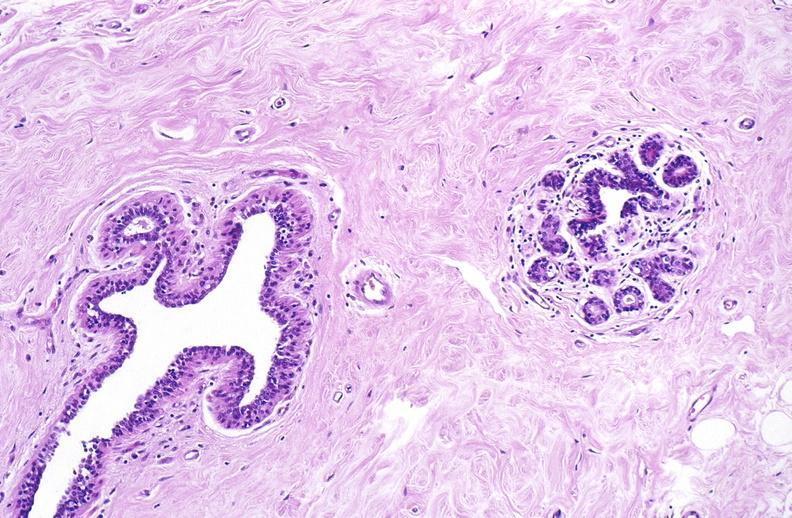does this image show normal breast?
Answer the question using a single word or phrase. Yes 